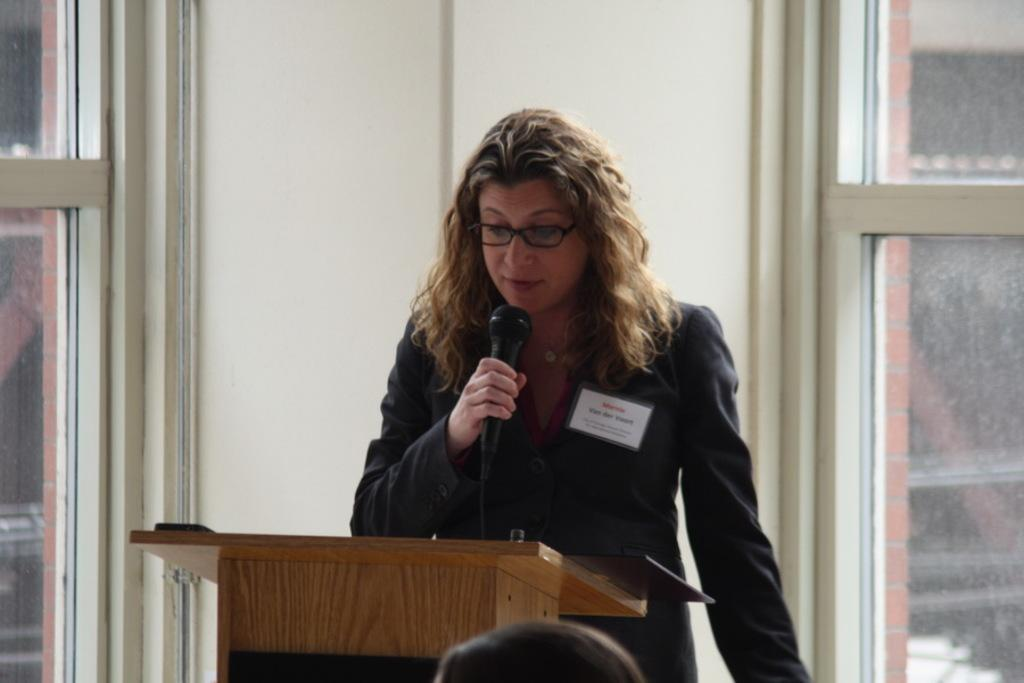What is the lady in the image doing? The lady is standing in the center of the image and holding a mic. What object is in front of the lady? There is a podium before the lady. What can be seen in the background of the image? There is a wall and windows in the background of the image. What type of fish can be seen swimming in the drain in the image? There is no drain or fish present in the image. 